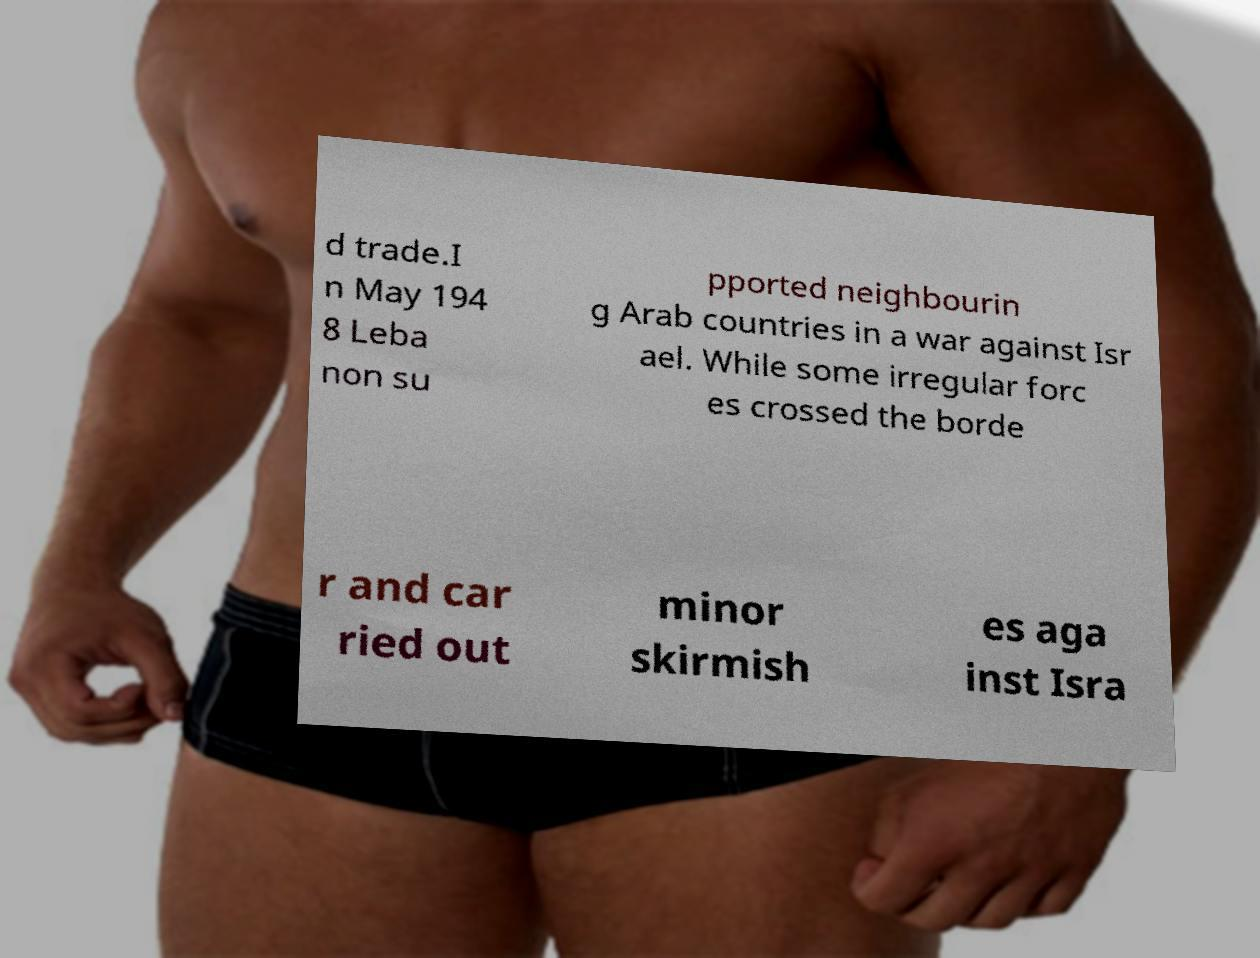Can you read and provide the text displayed in the image?This photo seems to have some interesting text. Can you extract and type it out for me? d trade.I n May 194 8 Leba non su pported neighbourin g Arab countries in a war against Isr ael. While some irregular forc es crossed the borde r and car ried out minor skirmish es aga inst Isra 